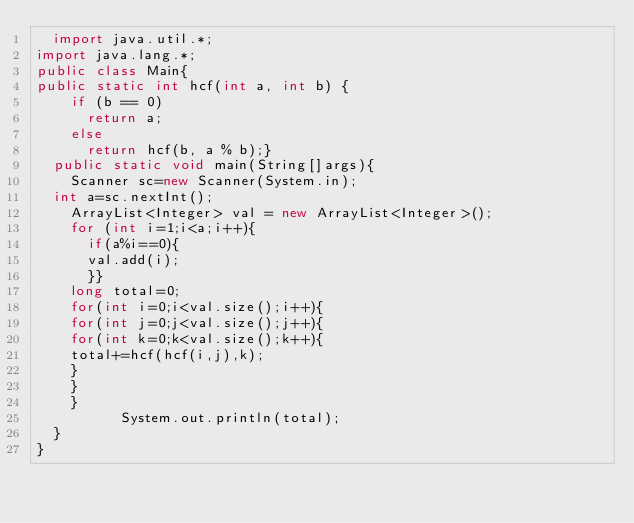<code> <loc_0><loc_0><loc_500><loc_500><_Java_>  import java.util.*;
import java.lang.*;
public class Main{
public static int hcf(int a, int b) {
		if (b == 0)
			return a;
		else
			return hcf(b, a % b);}
  public static void main(String[]args){
    Scanner sc=new Scanner(System.in);
  int a=sc.nextInt();
    ArrayList<Integer> val = new ArrayList<Integer>();
    for (int i=1;i<a;i++){
      if(a%i==0){
      val.add(i);
      }}
    long total=0;
    for(int i=0;i<val.size();i++){
    for(int j=0;j<val.size();j++){
    for(int k=0;k<val.size();k++){
    total+=hcf(hcf(i,j),k);
    }
    }
    }
          System.out.println(total);
  }
}
</code> 